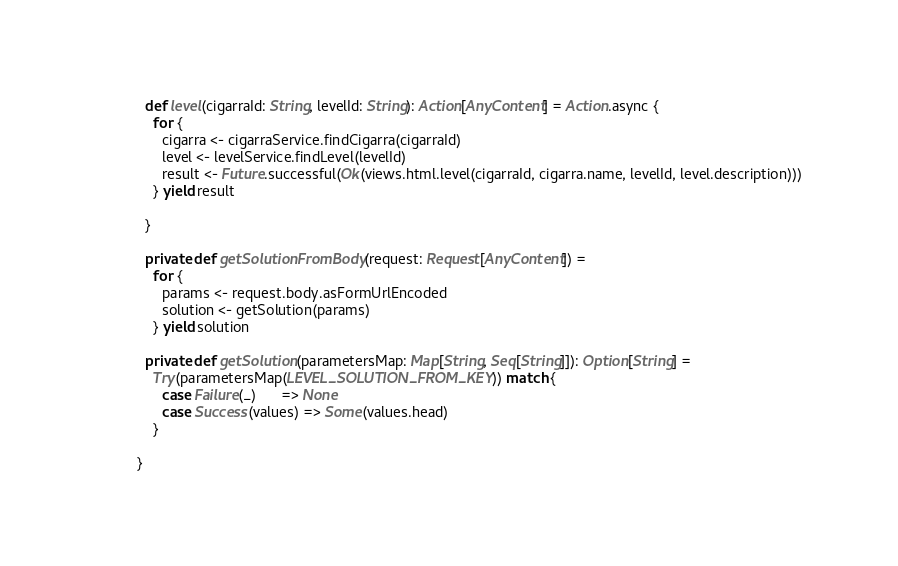Convert code to text. <code><loc_0><loc_0><loc_500><loc_500><_Scala_>
  def level(cigarraId: String, levelId: String): Action[AnyContent] = Action.async {
    for {
      cigarra <- cigarraService.findCigarra(cigarraId)
      level <- levelService.findLevel(levelId)
      result <- Future.successful(Ok(views.html.level(cigarraId, cigarra.name, levelId, level.description)))
    } yield result

  }

  private def getSolutionFromBody(request: Request[AnyContent]) =
    for {
      params <- request.body.asFormUrlEncoded
      solution <- getSolution(params)
    } yield solution

  private def getSolution(parametersMap: Map[String, Seq[String]]): Option[String] =
    Try(parametersMap(LEVEL_SOLUTION_FROM_KEY)) match {
      case Failure(_)      => None
      case Success(values) => Some(values.head)
    }

}
</code> 